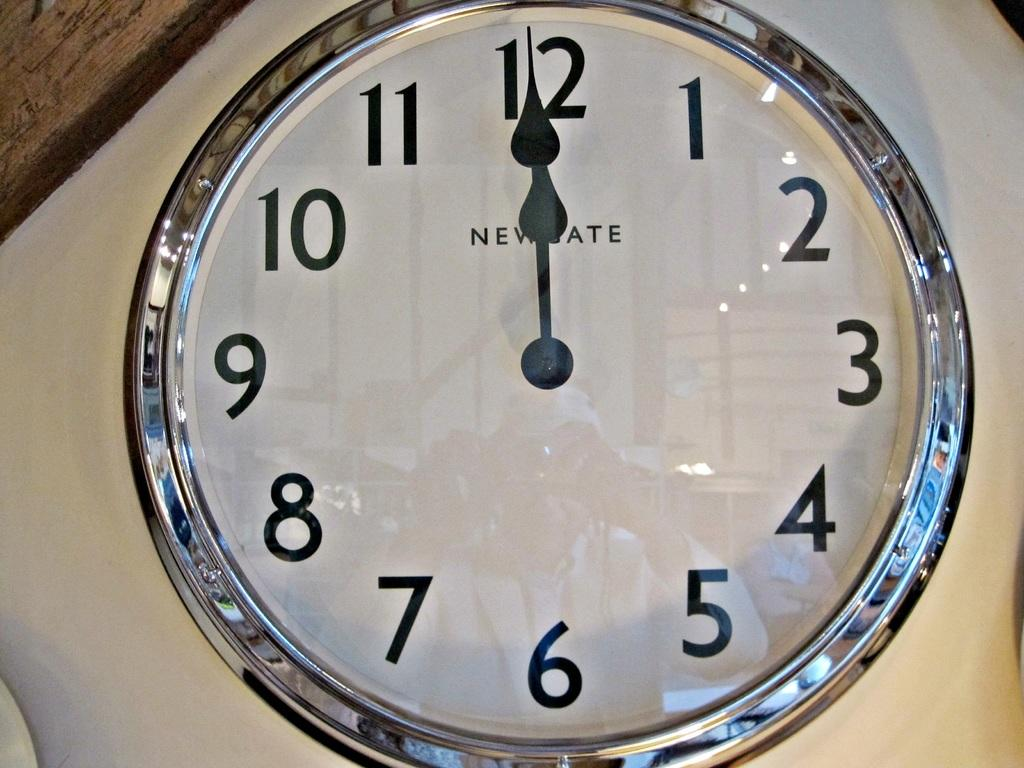<image>
Write a terse but informative summary of the picture. Clock which says NEWSTATE on the front of it. 